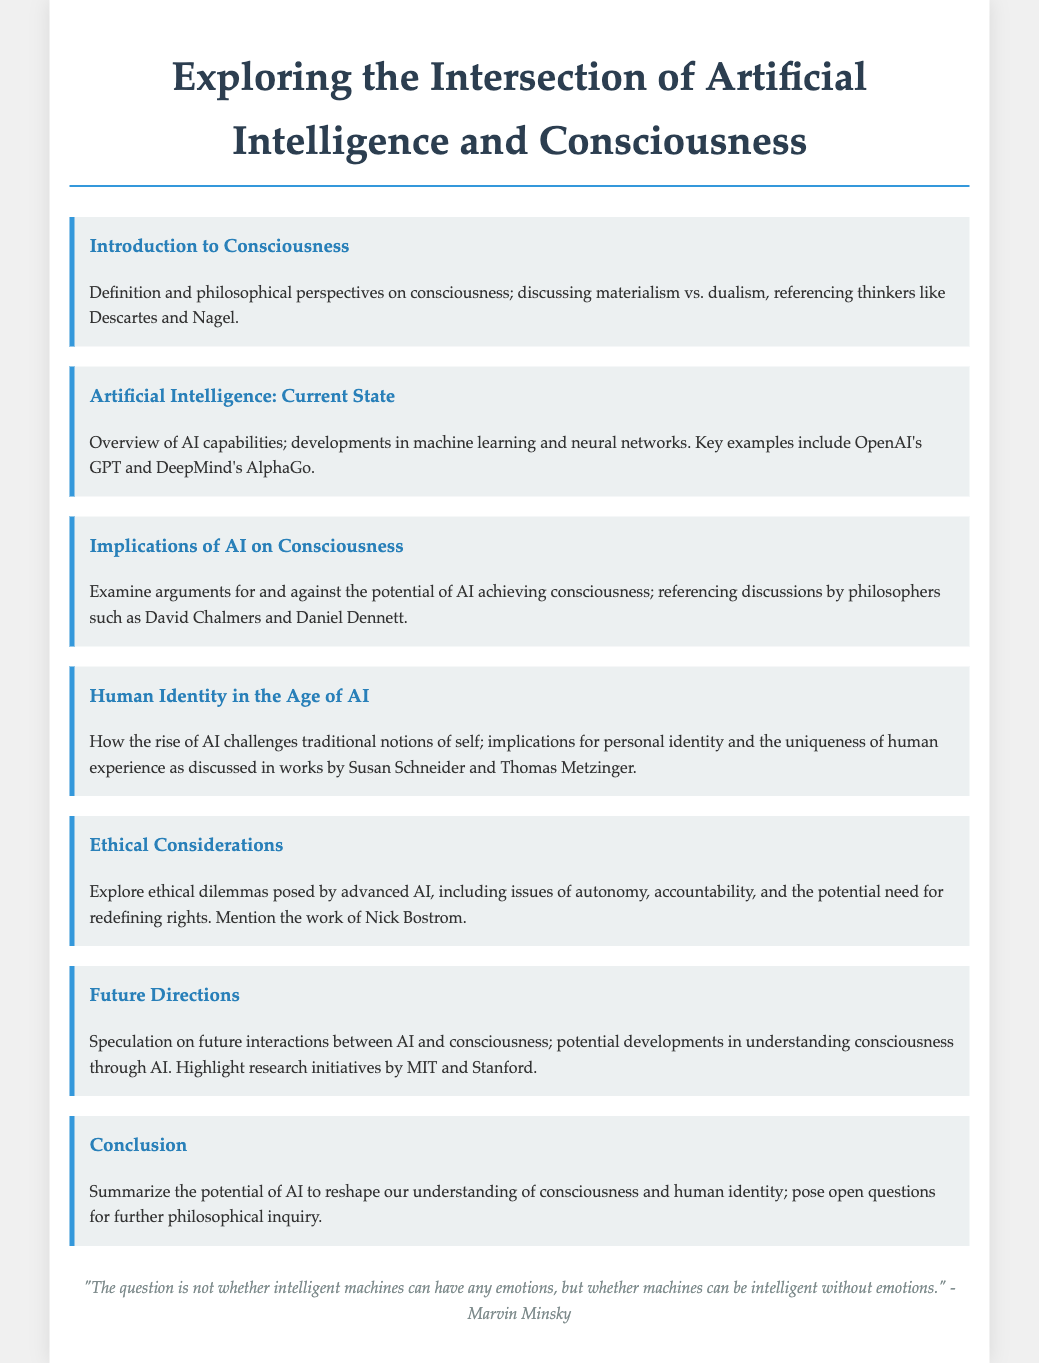What is the title of the presentation? The title of the presentation is found at the top of the document, summarizing the main topic.
Answer: Exploring the Intersection of Artificial Intelligence and Consciousness Who is referenced for discussing materialism vs. dualism? The slide on the Introduction to Consciousness mentions specific philosophers related to these perspectives.
Answer: Descartes and Nagel What does the slide on Ethical Considerations mention about Nick Bostrom? The slide highlights the significance of Nick Bostrom in addressing ethical dilemmas posed by advanced AI.
Answer: His work Which AI system is mentioned as an example in the Current State slide? The Current State slide provides examples of advancements in AI technologies through specific systems.
Answer: DeepMind's AlphaGo What philosophical thinkers are referenced regarding AI and consciousness? The slide examining AI's implications on consciousness cites notable philosophers involved in this discourse.
Answer: David Chalmers and Daniel Dennett What does the final slide pose for further inquiry? The Conclusion slide summarizes the discussion and suggests areas that need further exploration.
Answer: Open questions 